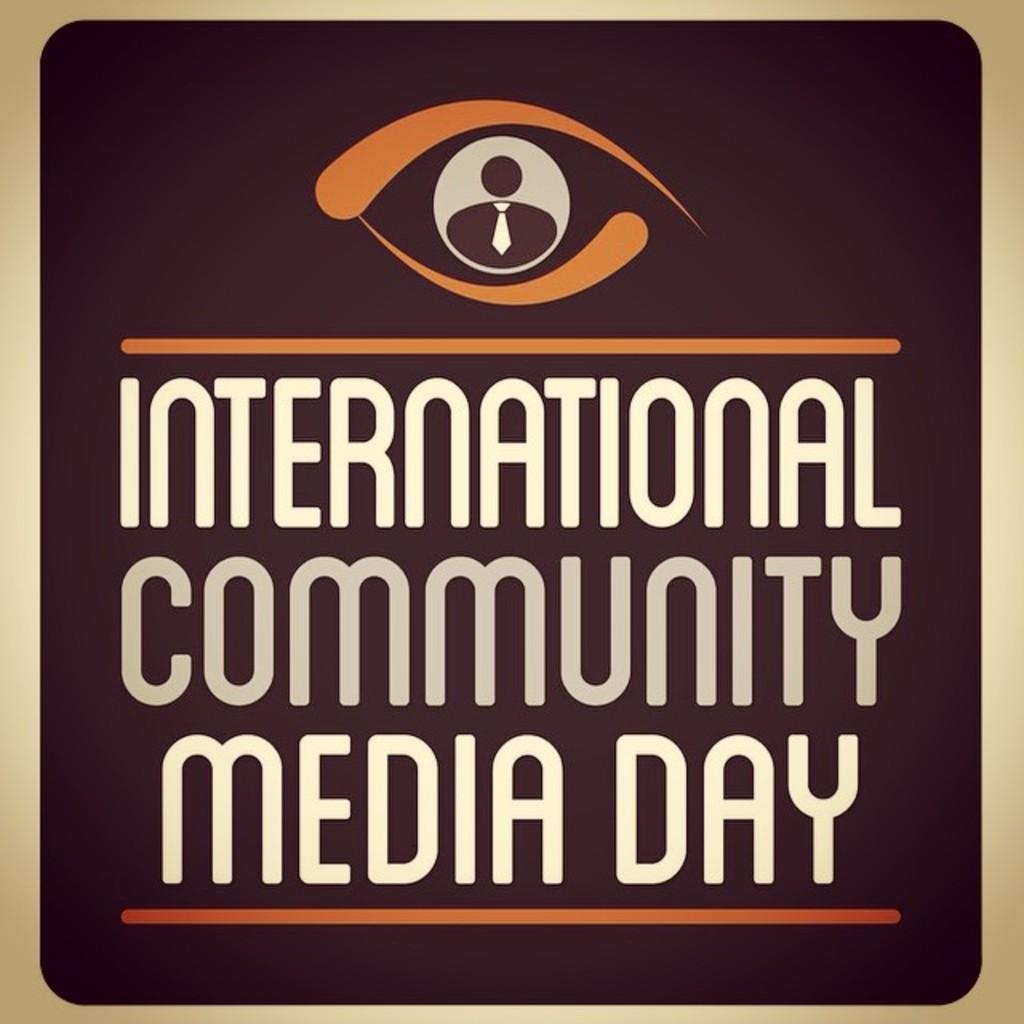<image>
Describe the image concisely. A sign that says International Community Media Day. 